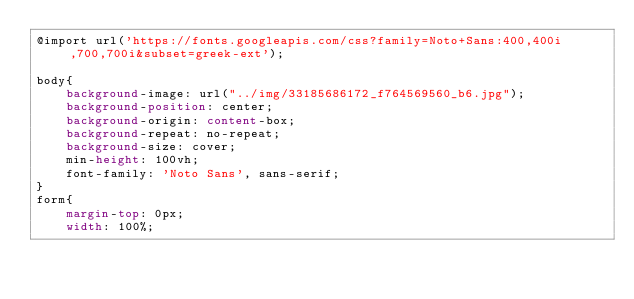Convert code to text. <code><loc_0><loc_0><loc_500><loc_500><_CSS_>@import url('https://fonts.googleapis.com/css?family=Noto+Sans:400,400i,700,700i&subset=greek-ext');

body{
	background-image: url("../img/33185686172_f764569560_b6.jpg");
	background-position: center;
    background-origin: content-box;
    background-repeat: no-repeat;
    background-size: cover;
    min-height: 100vh;
	font-family: 'Noto Sans', sans-serif;
}
form{
	margin-top: 0px;
    width: 100%;</code> 